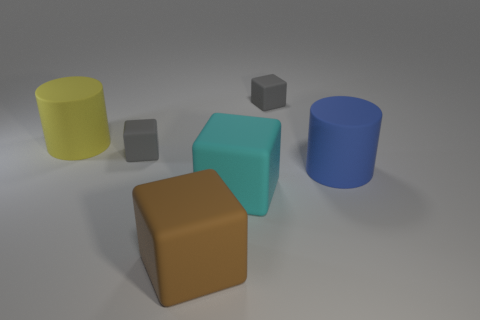Subtract 1 blocks. How many blocks are left? 3 Subtract all blue cubes. Subtract all red cylinders. How many cubes are left? 4 Add 1 big blue matte things. How many objects exist? 7 Subtract all cylinders. How many objects are left? 4 Add 3 big cubes. How many big cubes are left? 5 Add 1 small cylinders. How many small cylinders exist? 1 Subtract 0 purple cylinders. How many objects are left? 6 Subtract all blue rubber blocks. Subtract all tiny gray rubber objects. How many objects are left? 4 